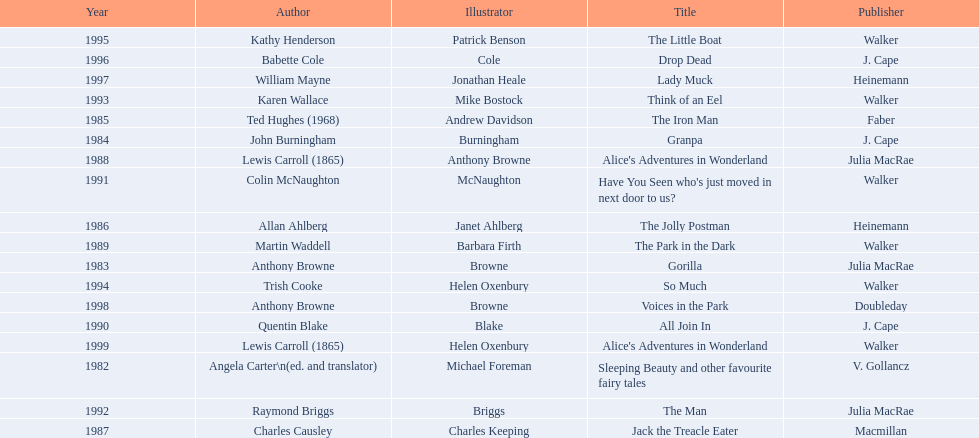Which author wrote the first award winner? Angela Carter. Can you parse all the data within this table? {'header': ['Year', 'Author', 'Illustrator', 'Title', 'Publisher'], 'rows': [['1995', 'Kathy Henderson', 'Patrick Benson', 'The Little Boat', 'Walker'], ['1996', 'Babette Cole', 'Cole', 'Drop Dead', 'J. Cape'], ['1997', 'William Mayne', 'Jonathan Heale', 'Lady Muck', 'Heinemann'], ['1993', 'Karen Wallace', 'Mike Bostock', 'Think of an Eel', 'Walker'], ['1985', 'Ted Hughes (1968)', 'Andrew Davidson', 'The Iron Man', 'Faber'], ['1984', 'John Burningham', 'Burningham', 'Granpa', 'J. Cape'], ['1988', 'Lewis Carroll (1865)', 'Anthony Browne', "Alice's Adventures in Wonderland", 'Julia MacRae'], ['1991', 'Colin McNaughton', 'McNaughton', "Have You Seen who's just moved in next door to us?", 'Walker'], ['1986', 'Allan Ahlberg', 'Janet Ahlberg', 'The Jolly Postman', 'Heinemann'], ['1989', 'Martin Waddell', 'Barbara Firth', 'The Park in the Dark', 'Walker'], ['1983', 'Anthony Browne', 'Browne', 'Gorilla', 'Julia MacRae'], ['1994', 'Trish Cooke', 'Helen Oxenbury', 'So Much', 'Walker'], ['1998', 'Anthony Browne', 'Browne', 'Voices in the Park', 'Doubleday'], ['1990', 'Quentin Blake', 'Blake', 'All Join In', 'J. Cape'], ['1999', 'Lewis Carroll (1865)', 'Helen Oxenbury', "Alice's Adventures in Wonderland", 'Walker'], ['1982', 'Angela Carter\\n(ed. and translator)', 'Michael Foreman', 'Sleeping Beauty and other favourite fairy tales', 'V. Gollancz'], ['1992', 'Raymond Briggs', 'Briggs', 'The Man', 'Julia MacRae'], ['1987', 'Charles Causley', 'Charles Keeping', 'Jack the Treacle Eater', 'Macmillan']]} 